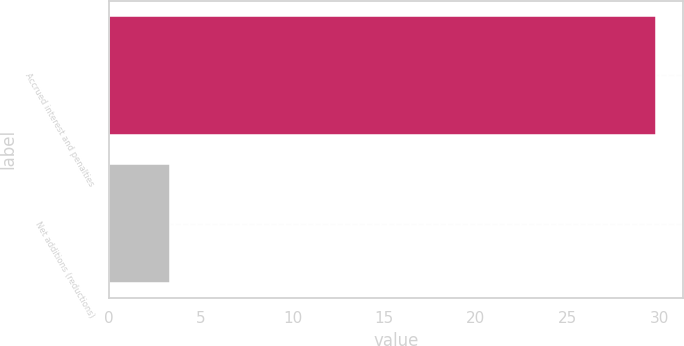<chart> <loc_0><loc_0><loc_500><loc_500><bar_chart><fcel>Accrued interest and penalties<fcel>Net additions (reductions)<nl><fcel>29.8<fcel>3.3<nl></chart> 